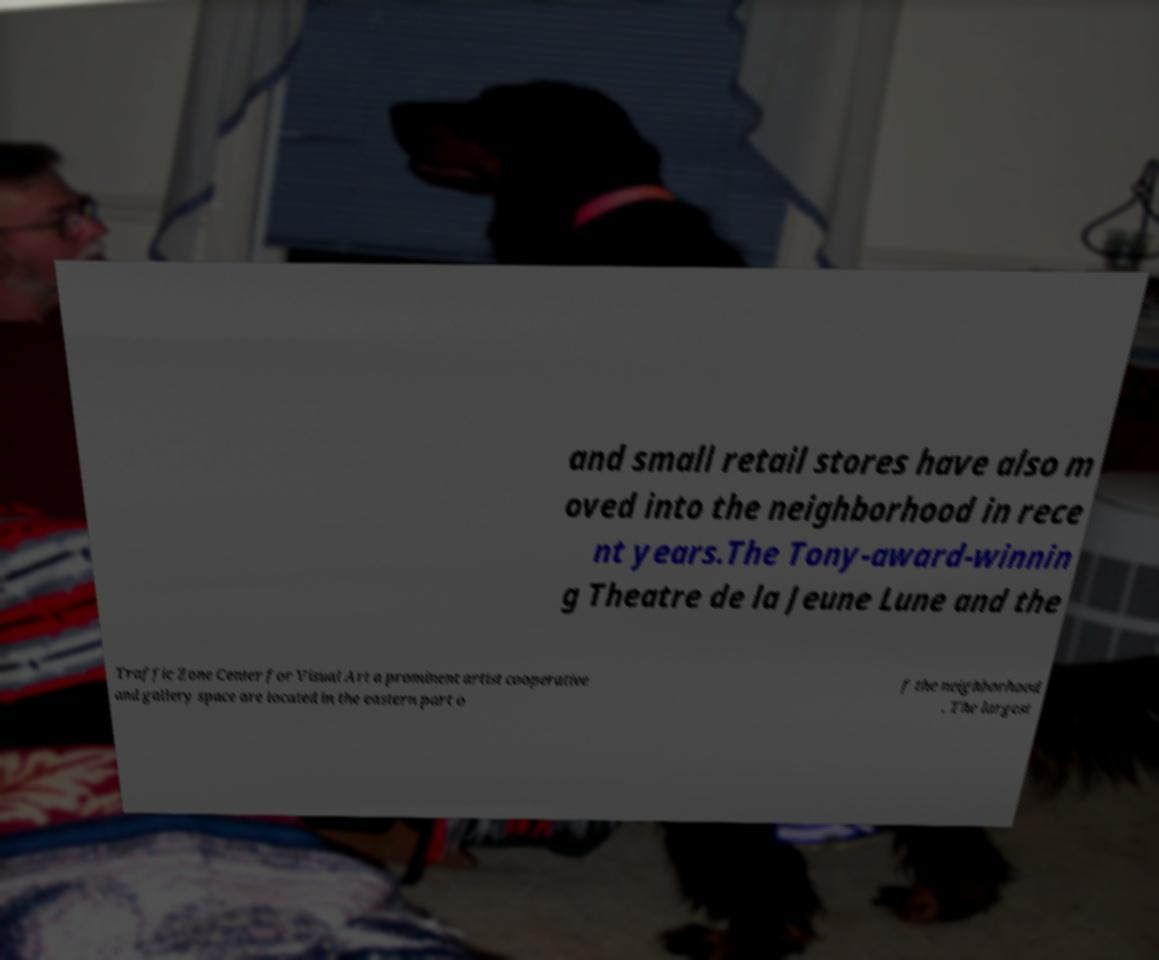I need the written content from this picture converted into text. Can you do that? and small retail stores have also m oved into the neighborhood in rece nt years.The Tony-award-winnin g Theatre de la Jeune Lune and the Traffic Zone Center for Visual Art a prominent artist cooperative and gallery space are located in the eastern part o f the neighborhood . The largest 